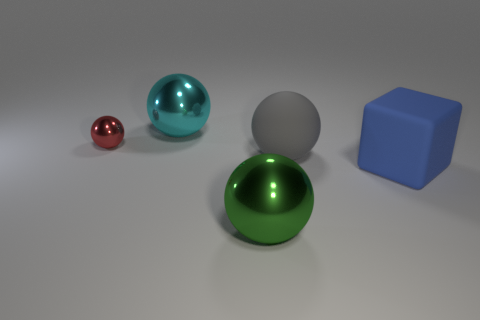Subtract all small red metal balls. How many balls are left? 3 Subtract all cyan balls. How many balls are left? 3 Add 1 large gray matte blocks. How many objects exist? 6 Subtract all balls. How many objects are left? 1 Subtract 3 spheres. How many spheres are left? 1 Subtract all red blocks. Subtract all gray cylinders. How many blocks are left? 1 Subtract all small blue shiny spheres. Subtract all red things. How many objects are left? 4 Add 3 green objects. How many green objects are left? 4 Add 5 big metallic objects. How many big metallic objects exist? 7 Subtract 0 purple balls. How many objects are left? 5 